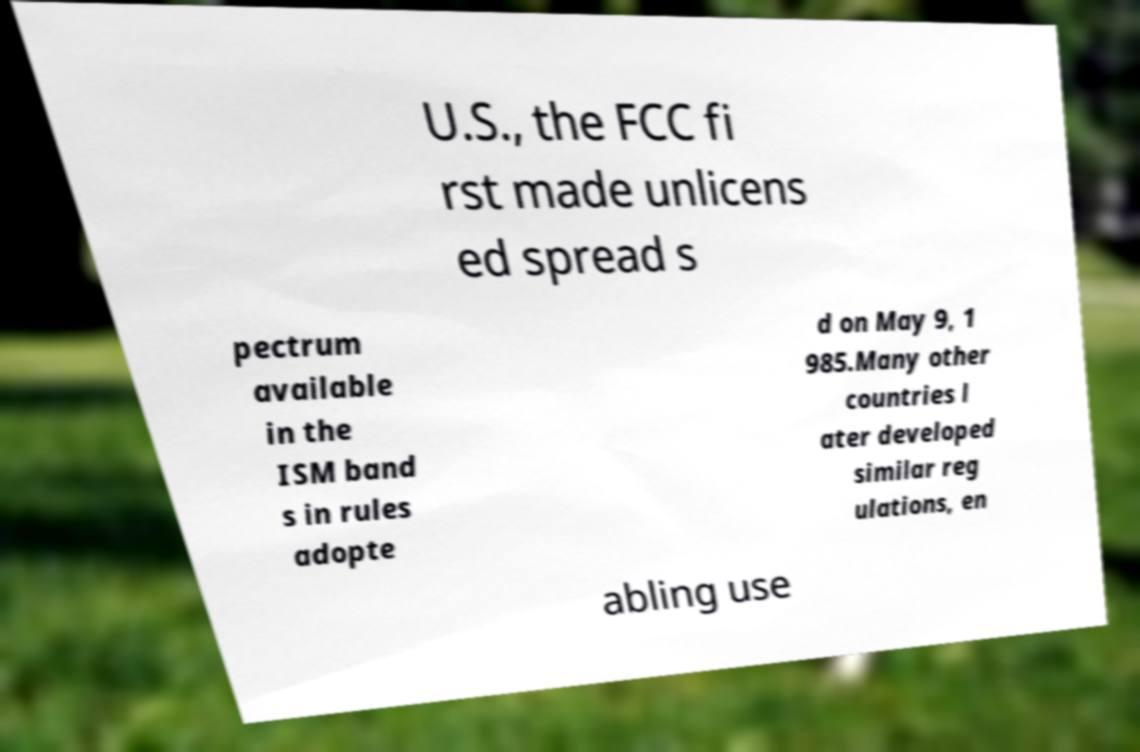I need the written content from this picture converted into text. Can you do that? U.S., the FCC fi rst made unlicens ed spread s pectrum available in the ISM band s in rules adopte d on May 9, 1 985.Many other countries l ater developed similar reg ulations, en abling use 